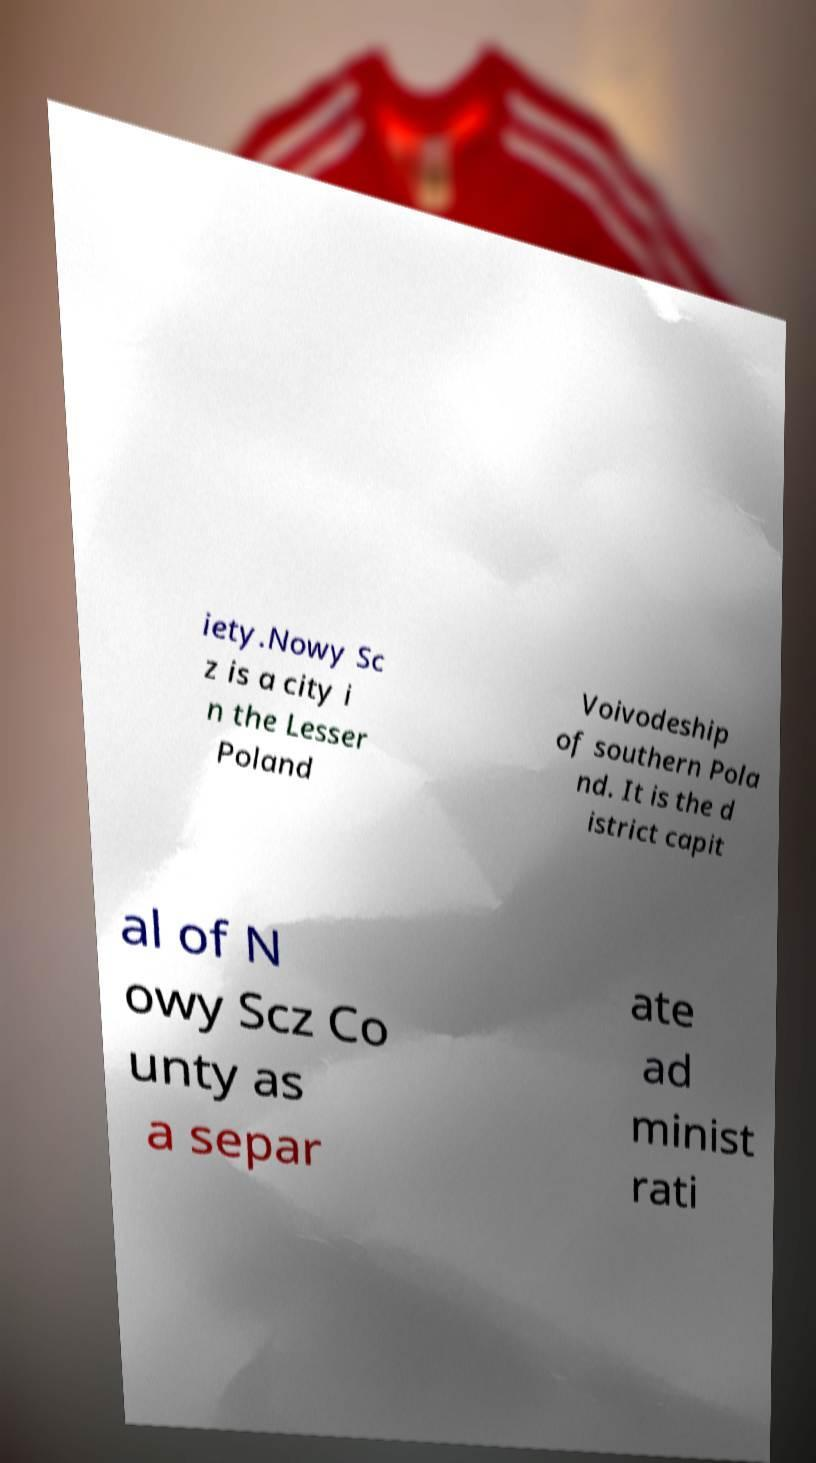Could you assist in decoding the text presented in this image and type it out clearly? iety.Nowy Sc z is a city i n the Lesser Poland Voivodeship of southern Pola nd. It is the d istrict capit al of N owy Scz Co unty as a separ ate ad minist rati 